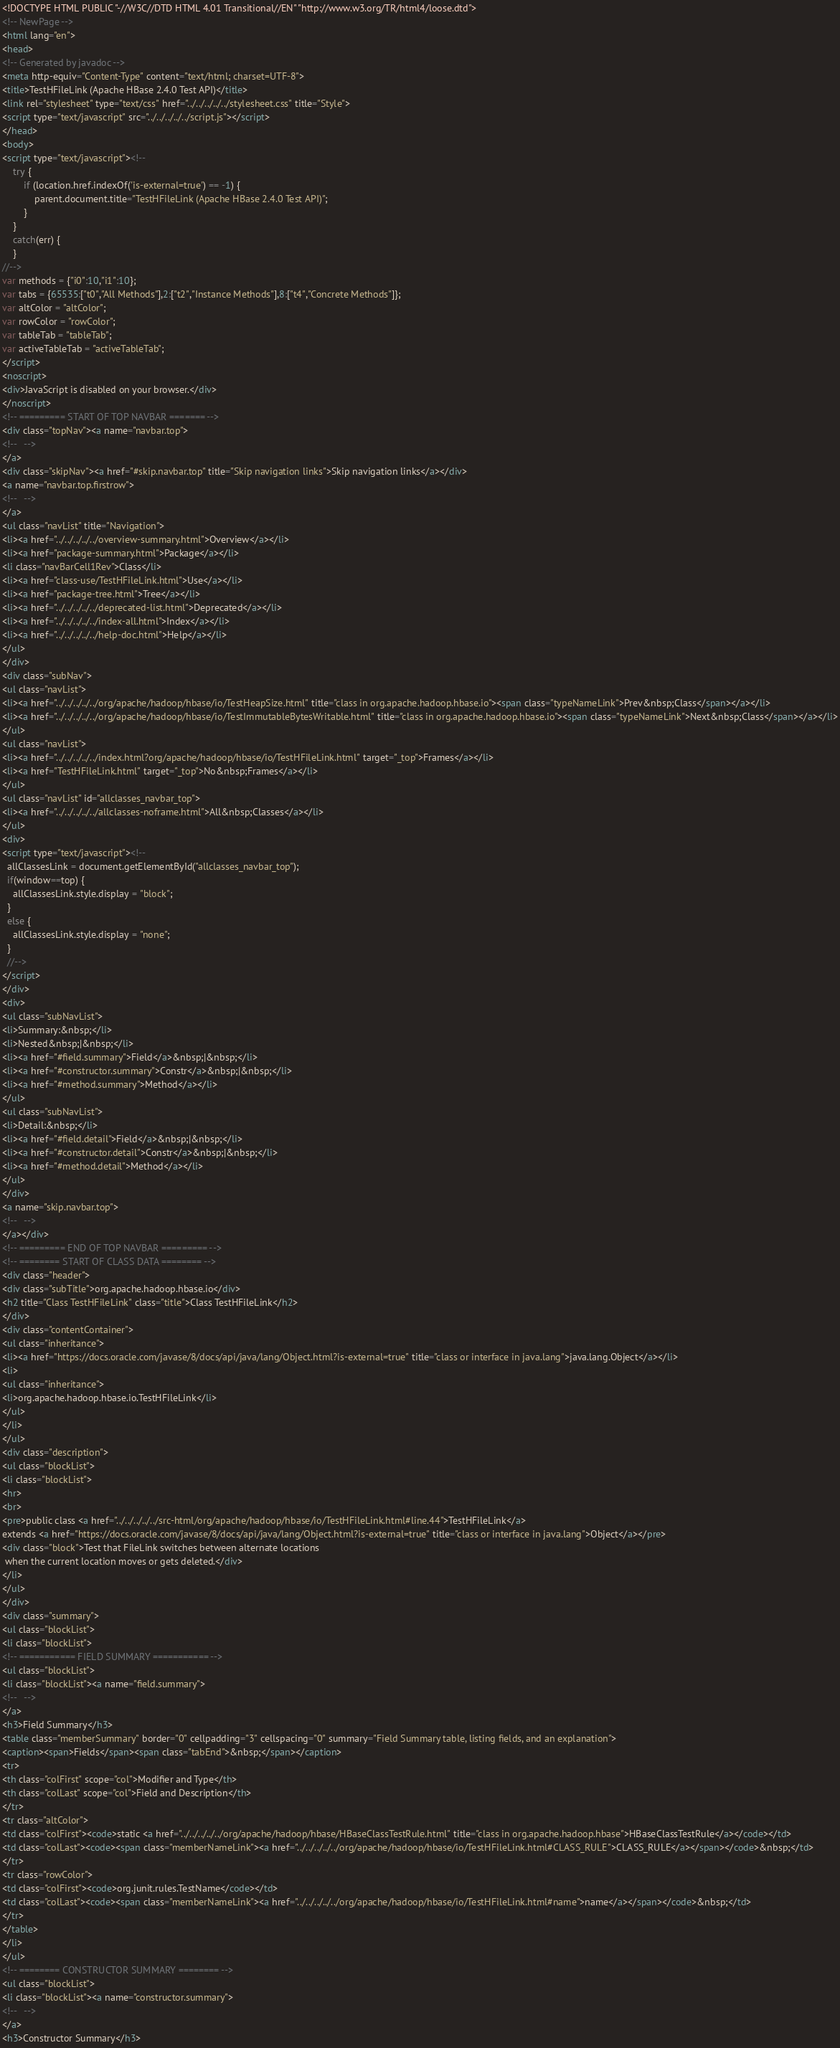Convert code to text. <code><loc_0><loc_0><loc_500><loc_500><_HTML_><!DOCTYPE HTML PUBLIC "-//W3C//DTD HTML 4.01 Transitional//EN" "http://www.w3.org/TR/html4/loose.dtd">
<!-- NewPage -->
<html lang="en">
<head>
<!-- Generated by javadoc -->
<meta http-equiv="Content-Type" content="text/html; charset=UTF-8">
<title>TestHFileLink (Apache HBase 2.4.0 Test API)</title>
<link rel="stylesheet" type="text/css" href="../../../../../stylesheet.css" title="Style">
<script type="text/javascript" src="../../../../../script.js"></script>
</head>
<body>
<script type="text/javascript"><!--
    try {
        if (location.href.indexOf('is-external=true') == -1) {
            parent.document.title="TestHFileLink (Apache HBase 2.4.0 Test API)";
        }
    }
    catch(err) {
    }
//-->
var methods = {"i0":10,"i1":10};
var tabs = {65535:["t0","All Methods"],2:["t2","Instance Methods"],8:["t4","Concrete Methods"]};
var altColor = "altColor";
var rowColor = "rowColor";
var tableTab = "tableTab";
var activeTableTab = "activeTableTab";
</script>
<noscript>
<div>JavaScript is disabled on your browser.</div>
</noscript>
<!-- ========= START OF TOP NAVBAR ======= -->
<div class="topNav"><a name="navbar.top">
<!--   -->
</a>
<div class="skipNav"><a href="#skip.navbar.top" title="Skip navigation links">Skip navigation links</a></div>
<a name="navbar.top.firstrow">
<!--   -->
</a>
<ul class="navList" title="Navigation">
<li><a href="../../../../../overview-summary.html">Overview</a></li>
<li><a href="package-summary.html">Package</a></li>
<li class="navBarCell1Rev">Class</li>
<li><a href="class-use/TestHFileLink.html">Use</a></li>
<li><a href="package-tree.html">Tree</a></li>
<li><a href="../../../../../deprecated-list.html">Deprecated</a></li>
<li><a href="../../../../../index-all.html">Index</a></li>
<li><a href="../../../../../help-doc.html">Help</a></li>
</ul>
</div>
<div class="subNav">
<ul class="navList">
<li><a href="../../../../../org/apache/hadoop/hbase/io/TestHeapSize.html" title="class in org.apache.hadoop.hbase.io"><span class="typeNameLink">Prev&nbsp;Class</span></a></li>
<li><a href="../../../../../org/apache/hadoop/hbase/io/TestImmutableBytesWritable.html" title="class in org.apache.hadoop.hbase.io"><span class="typeNameLink">Next&nbsp;Class</span></a></li>
</ul>
<ul class="navList">
<li><a href="../../../../../index.html?org/apache/hadoop/hbase/io/TestHFileLink.html" target="_top">Frames</a></li>
<li><a href="TestHFileLink.html" target="_top">No&nbsp;Frames</a></li>
</ul>
<ul class="navList" id="allclasses_navbar_top">
<li><a href="../../../../../allclasses-noframe.html">All&nbsp;Classes</a></li>
</ul>
<div>
<script type="text/javascript"><!--
  allClassesLink = document.getElementById("allclasses_navbar_top");
  if(window==top) {
    allClassesLink.style.display = "block";
  }
  else {
    allClassesLink.style.display = "none";
  }
  //-->
</script>
</div>
<div>
<ul class="subNavList">
<li>Summary:&nbsp;</li>
<li>Nested&nbsp;|&nbsp;</li>
<li><a href="#field.summary">Field</a>&nbsp;|&nbsp;</li>
<li><a href="#constructor.summary">Constr</a>&nbsp;|&nbsp;</li>
<li><a href="#method.summary">Method</a></li>
</ul>
<ul class="subNavList">
<li>Detail:&nbsp;</li>
<li><a href="#field.detail">Field</a>&nbsp;|&nbsp;</li>
<li><a href="#constructor.detail">Constr</a>&nbsp;|&nbsp;</li>
<li><a href="#method.detail">Method</a></li>
</ul>
</div>
<a name="skip.navbar.top">
<!--   -->
</a></div>
<!-- ========= END OF TOP NAVBAR ========= -->
<!-- ======== START OF CLASS DATA ======== -->
<div class="header">
<div class="subTitle">org.apache.hadoop.hbase.io</div>
<h2 title="Class TestHFileLink" class="title">Class TestHFileLink</h2>
</div>
<div class="contentContainer">
<ul class="inheritance">
<li><a href="https://docs.oracle.com/javase/8/docs/api/java/lang/Object.html?is-external=true" title="class or interface in java.lang">java.lang.Object</a></li>
<li>
<ul class="inheritance">
<li>org.apache.hadoop.hbase.io.TestHFileLink</li>
</ul>
</li>
</ul>
<div class="description">
<ul class="blockList">
<li class="blockList">
<hr>
<br>
<pre>public class <a href="../../../../../src-html/org/apache/hadoop/hbase/io/TestHFileLink.html#line.44">TestHFileLink</a>
extends <a href="https://docs.oracle.com/javase/8/docs/api/java/lang/Object.html?is-external=true" title="class or interface in java.lang">Object</a></pre>
<div class="block">Test that FileLink switches between alternate locations
 when the current location moves or gets deleted.</div>
</li>
</ul>
</div>
<div class="summary">
<ul class="blockList">
<li class="blockList">
<!-- =========== FIELD SUMMARY =========== -->
<ul class="blockList">
<li class="blockList"><a name="field.summary">
<!--   -->
</a>
<h3>Field Summary</h3>
<table class="memberSummary" border="0" cellpadding="3" cellspacing="0" summary="Field Summary table, listing fields, and an explanation">
<caption><span>Fields</span><span class="tabEnd">&nbsp;</span></caption>
<tr>
<th class="colFirst" scope="col">Modifier and Type</th>
<th class="colLast" scope="col">Field and Description</th>
</tr>
<tr class="altColor">
<td class="colFirst"><code>static <a href="../../../../../org/apache/hadoop/hbase/HBaseClassTestRule.html" title="class in org.apache.hadoop.hbase">HBaseClassTestRule</a></code></td>
<td class="colLast"><code><span class="memberNameLink"><a href="../../../../../org/apache/hadoop/hbase/io/TestHFileLink.html#CLASS_RULE">CLASS_RULE</a></span></code>&nbsp;</td>
</tr>
<tr class="rowColor">
<td class="colFirst"><code>org.junit.rules.TestName</code></td>
<td class="colLast"><code><span class="memberNameLink"><a href="../../../../../org/apache/hadoop/hbase/io/TestHFileLink.html#name">name</a></span></code>&nbsp;</td>
</tr>
</table>
</li>
</ul>
<!-- ======== CONSTRUCTOR SUMMARY ======== -->
<ul class="blockList">
<li class="blockList"><a name="constructor.summary">
<!--   -->
</a>
<h3>Constructor Summary</h3></code> 